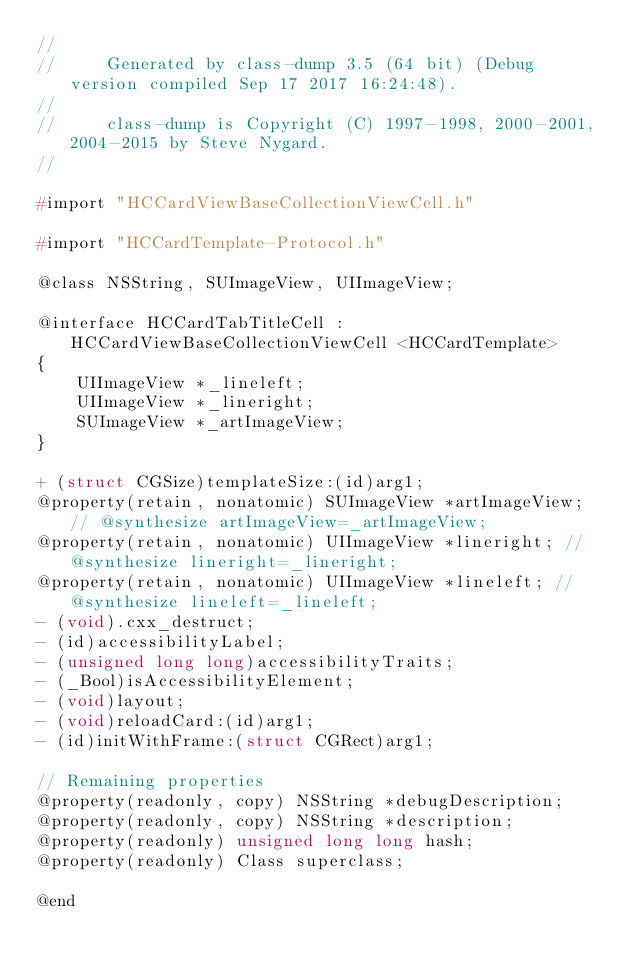<code> <loc_0><loc_0><loc_500><loc_500><_C_>//
//     Generated by class-dump 3.5 (64 bit) (Debug version compiled Sep 17 2017 16:24:48).
//
//     class-dump is Copyright (C) 1997-1998, 2000-2001, 2004-2015 by Steve Nygard.
//

#import "HCCardViewBaseCollectionViewCell.h"

#import "HCCardTemplate-Protocol.h"

@class NSString, SUImageView, UIImageView;

@interface HCCardTabTitleCell : HCCardViewBaseCollectionViewCell <HCCardTemplate>
{
    UIImageView *_lineleft;
    UIImageView *_lineright;
    SUImageView *_artImageView;
}

+ (struct CGSize)templateSize:(id)arg1;
@property(retain, nonatomic) SUImageView *artImageView; // @synthesize artImageView=_artImageView;
@property(retain, nonatomic) UIImageView *lineright; // @synthesize lineright=_lineright;
@property(retain, nonatomic) UIImageView *lineleft; // @synthesize lineleft=_lineleft;
- (void).cxx_destruct;
- (id)accessibilityLabel;
- (unsigned long long)accessibilityTraits;
- (_Bool)isAccessibilityElement;
- (void)layout;
- (void)reloadCard:(id)arg1;
- (id)initWithFrame:(struct CGRect)arg1;

// Remaining properties
@property(readonly, copy) NSString *debugDescription;
@property(readonly, copy) NSString *description;
@property(readonly) unsigned long long hash;
@property(readonly) Class superclass;

@end

</code> 